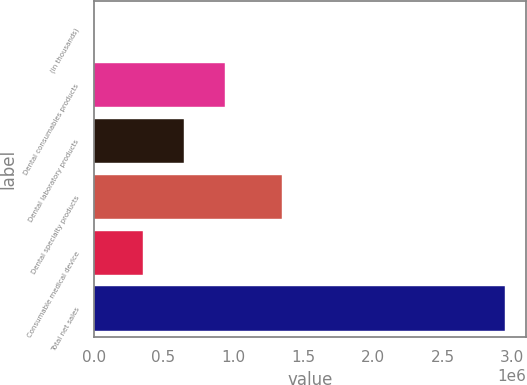<chart> <loc_0><loc_0><loc_500><loc_500><bar_chart><fcel>(in thousands)<fcel>Dental consumables products<fcel>Dental laboratory products<fcel>Dental specialty products<fcel>Consumable medical device<fcel>Total net sales<nl><fcel>2013<fcel>943089<fcel>648214<fcel>1.34742e+06<fcel>353338<fcel>2.95077e+06<nl></chart> 